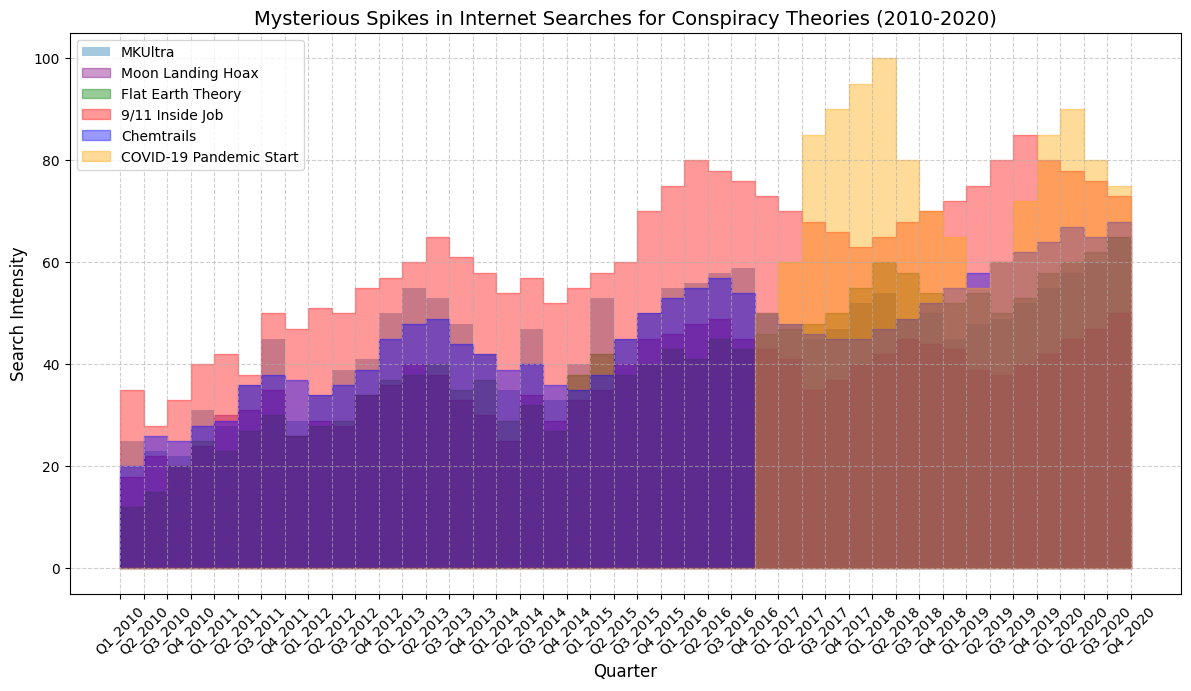Which conspiracy theory experienced the highest surge in searches around early 2020? To determine this, identify the theory with the greatest search intensity spike in early 2020. The orange section (COVID-19 Pandemic Start) skyrockets in Q1 and Q2 of 2020.
Answer: COVID-19 Pandemic Start How do search trends for MKUltra and Flat Earth Theory compare at their peaks? Compare the peak values and dates for both theories. MKUltra peaks roughly around 65 in Q4 2020, while Flat Earth Theory peaks around 65 in Q4 2020 as well.
Answer: Both peak at 65 in Q4 2020 Did Chemtrails or Moon Landing Hoax have a higher search intensity in Q2 2015? Look at Q2 2015 values for both theories. Chemtrails is blue, Moon Landing Hoax is purple. Chemtrails is higher.
Answer: Chemtrails What is the trend pattern for 9/11 Inside Job searches over the decade? Evaluate the red section's general direction. It fluctuates but has an overall increasing trend, peaking in Q3 2020 and slightly decreasing.
Answer: Increasing, peaking in Q3 2020 Calculate the difference in search intensity for Flat Earth Theory between Q1 2018 and Q2 2018. Subtract Flat Earth Theory values in Q1 2018 (50) from Q2 2018 (55).
Answer: 5 Was there more interest in Moon Landing Hoax or Chemtrails in Q1 2014? Compare values in Q1 2014 for purple (Moon Landing Hoax) and blue (Chemtrails). Chemtrails appears higher.
Answer: Chemtrails When did MKUltra first reach a search intensity of 50? Identify the first time MKUltra (yellow) surpasses or reaches 50. This occurs in Q1 2013.
Answer: Q1 2013 Which conspiracy theory showed a significant increase from Q1 2010 to Q4 2020? Look for overall spikes from start to end. COVID-19 (orange) shows a dramatic surge starting Q1 2020.
Answer: COVID-19 Pandemic Start Compare the search trend for Chemtrails from Q1 2015 to Q1 2016. Track the blue section from Q1 2015 to Q1 2016. It increases from 35 in Q1 2015 to 50 in Q1 2016.
Answer: Increasing from 35 to 50 